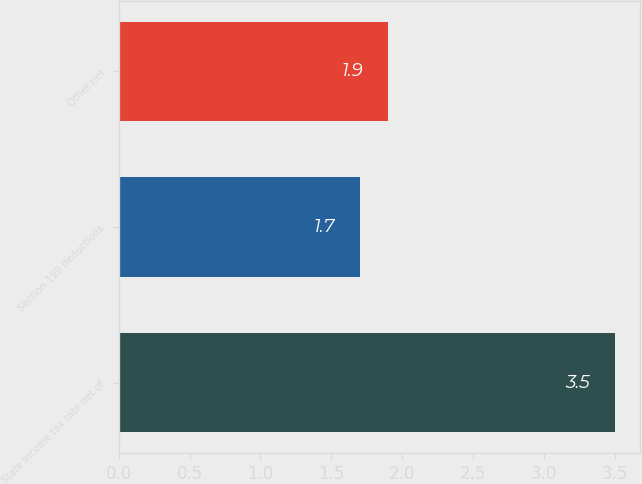<chart> <loc_0><loc_0><loc_500><loc_500><bar_chart><fcel>State income tax rate net of<fcel>Section 199 deductions<fcel>Other net<nl><fcel>3.5<fcel>1.7<fcel>1.9<nl></chart> 